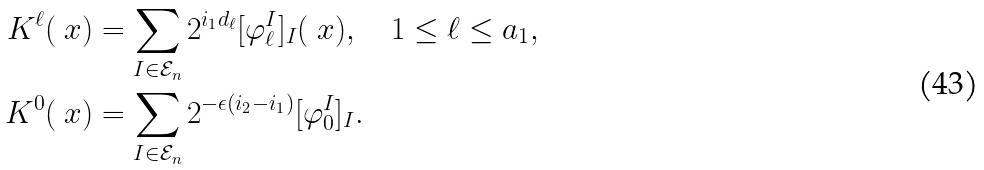<formula> <loc_0><loc_0><loc_500><loc_500>K ^ { \ell } ( \ x ) & = \sum _ { I \in \mathcal { E } _ { n } } 2 ^ { i _ { 1 } d _ { \ell } } [ \varphi ^ { I } _ { \ell } ] _ { I } ( \ x ) , \quad 1 \leq \ell \leq a _ { 1 } , \\ K ^ { 0 } ( \ x ) & = \sum _ { I \in \mathcal { E } _ { n } } 2 ^ { - \epsilon ( i _ { 2 } - i _ { 1 } ) } [ \varphi _ { 0 } ^ { I } ] _ { I } .</formula> 